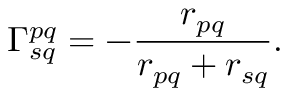Convert formula to latex. <formula><loc_0><loc_0><loc_500><loc_500>\Gamma _ { s q } ^ { p q } = - \frac { r _ { p q } } { r _ { p q } + r _ { s q } } .</formula> 